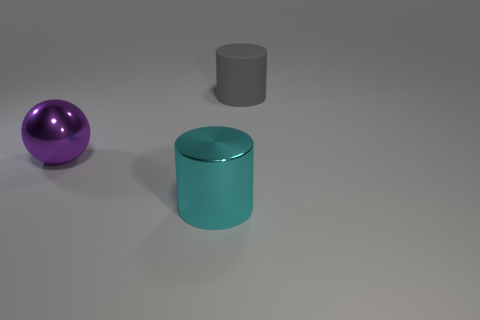Add 1 large shiny cylinders. How many objects exist? 4 Subtract all balls. How many objects are left? 2 Subtract 0 yellow cylinders. How many objects are left? 3 Subtract all tiny green objects. Subtract all metallic cylinders. How many objects are left? 2 Add 1 large cyan metal things. How many large cyan metal things are left? 2 Add 2 red metallic blocks. How many red metallic blocks exist? 2 